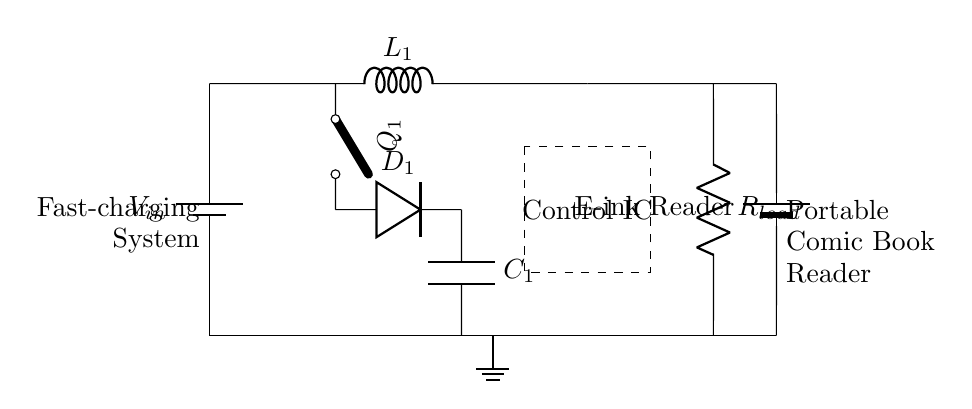What type of converter is used in this circuit? This circuit uses a buck converter, which is indicated by the presence of the inductor (L) and the associated switching elements (Q and D). A buck converter steps down the voltage from the input to a lower output voltage.
Answer: Buck converter What does the control IC do in this circuit? The control IC manages the operation of the buck converter by regulating the switching of the transistor (Q) to ensure that the output voltage is stable and appropriately sized for the load. It is necessary for efficient charging of the e-ink reader.
Answer: Regulates What is the purpose of the inductor in this fast-charging system? The inductor in a buck converter is used to store energy temporarily while controlling the current flow. It helps smooth the output voltage by reducing voltage spikes and providing a steady current to the load.
Answer: Energy storage What is the load represented in this circuit? The load in this circuit is represented by the resistor (R) labeled as the load which stands for the device being powered, in this case, the e-ink reader. It absorbs the current supplied by the converter.
Answer: E-ink reader How many main components are used in this fast-charging circuit? The main components in this fast-charging circuit include several distinct elements: the battery, the buck converter parts (inductor, switch, diode, capacitor, and control IC), and the load resistor. Counting these gives a total of at least six main components.
Answer: Six components What is the significance of the diode in this charging circuit? The diode in this circuit prevents backflow of current from the load to the buck converter when the switch (Q) is off. This maintains the directionality of the current flow essential for efficient charging and protects the circuit components.
Answer: Prevents backflow What does "fast-charging" imply in the context of this circuit? "Fast-charging" in this context implies that the circuit is designed to supply power rapidly to the e-ink reader, utilizing a buck converter that can efficiently convert input power to a suitable output level quickly, allowing shorter recharging times.
Answer: Rapid power supply 